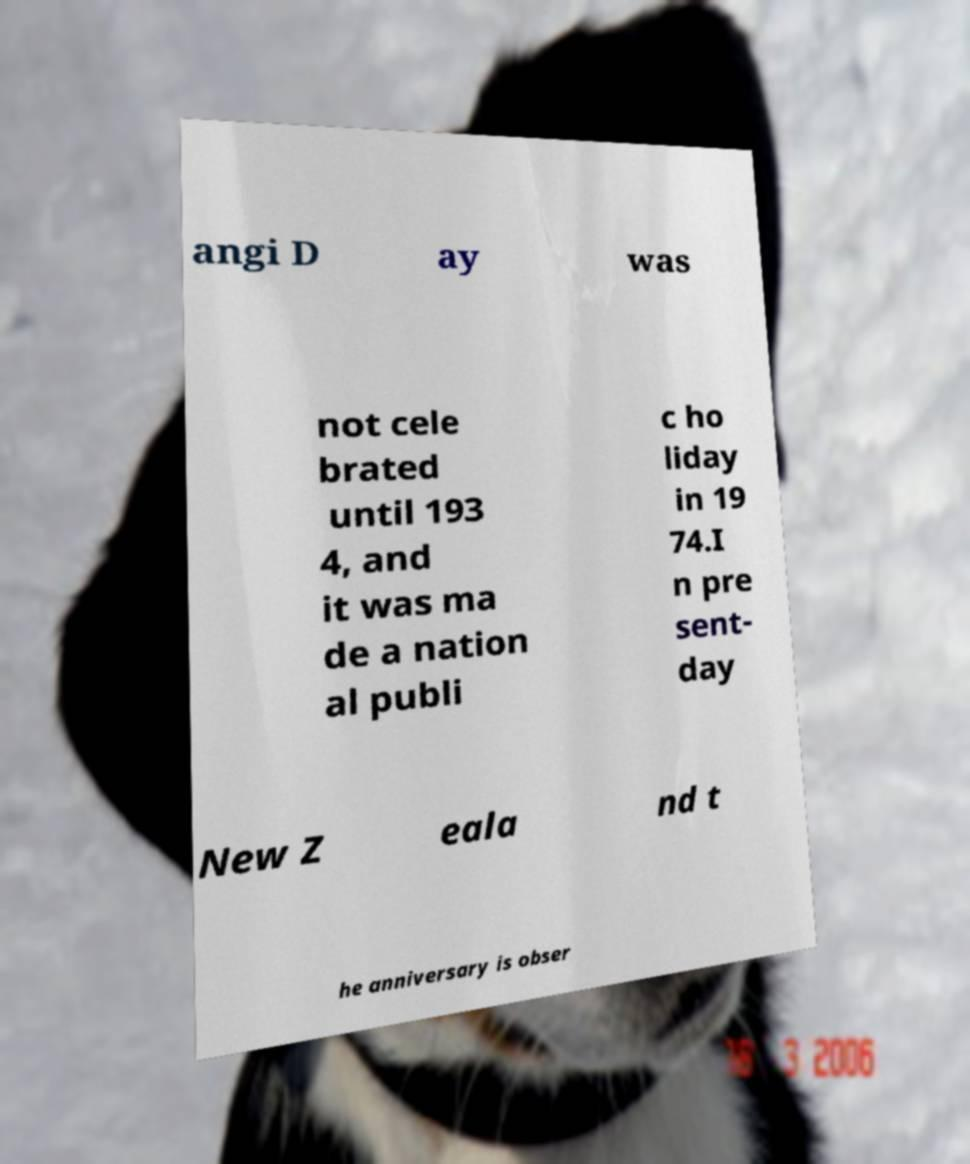Could you extract and type out the text from this image? angi D ay was not cele brated until 193 4, and it was ma de a nation al publi c ho liday in 19 74.I n pre sent- day New Z eala nd t he anniversary is obser 